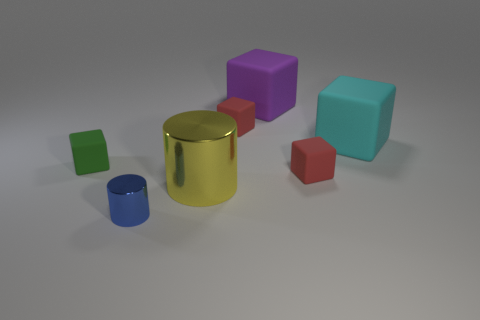Subtract all red rubber blocks. How many blocks are left? 3 Subtract all purple cubes. How many cubes are left? 4 Subtract all blue cubes. Subtract all blue balls. How many cubes are left? 5 Add 3 large objects. How many objects exist? 10 Subtract all cubes. How many objects are left? 2 Add 1 big cyan blocks. How many big cyan blocks are left? 2 Add 2 tiny green matte cubes. How many tiny green matte cubes exist? 3 Subtract 0 yellow spheres. How many objects are left? 7 Subtract all small blue objects. Subtract all tiny cylinders. How many objects are left? 5 